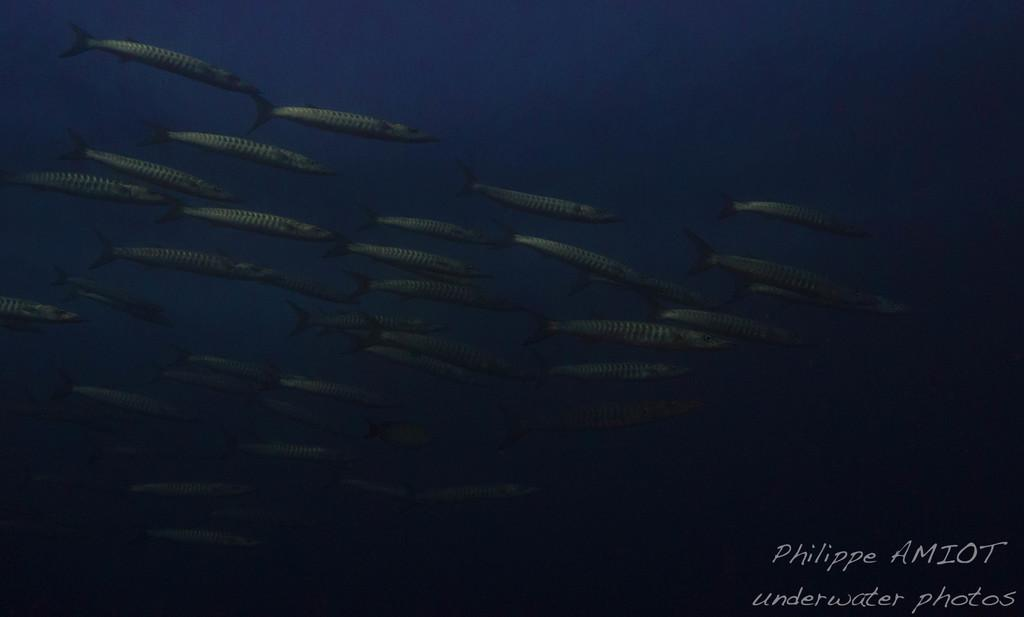What type of animals can be seen in the image? There are fishes in the image. What color is the water in the image? The water is blue in color. Is there any additional mark or feature at the bottom of the image? Yes, there is a watermark at the bottom of the image. Can you tell me how many adjustments were made to the sweater in the image? There is no sweater present in the image, and therefore no adjustments can be observed. What type of cave is visible in the image? There is no cave present in the image. 